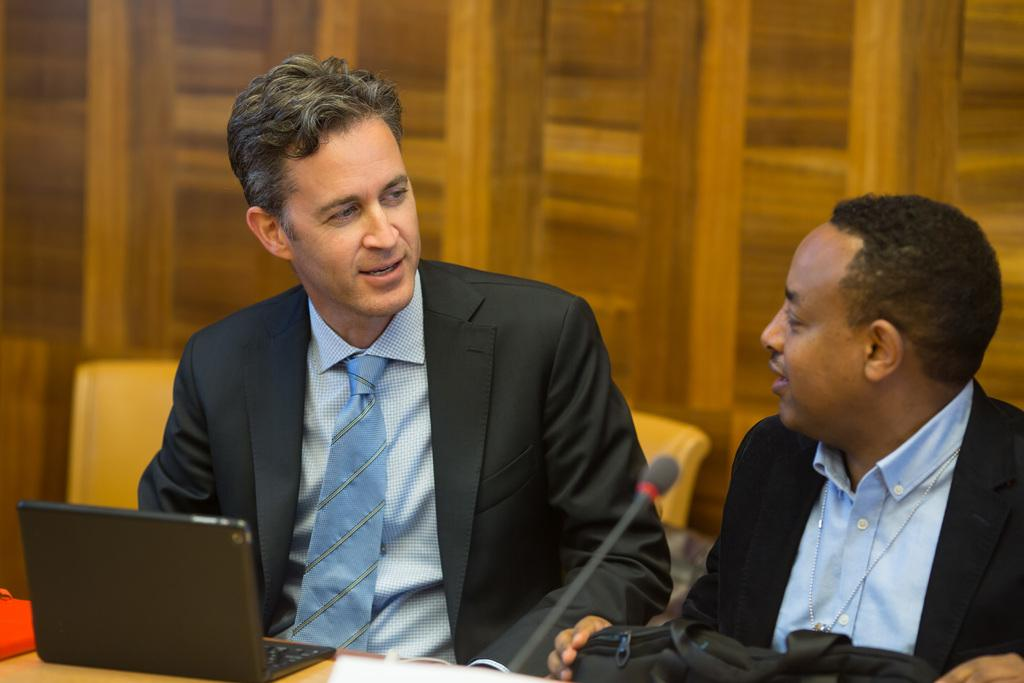Who or what can be seen in the image? There are people in the image. What object is present that is typically used for amplifying sound? There is a microphone (mike) in the image. What is located in the foreground of the image? There is a table with objects on it in the foreground. What type of furniture is present in the image? There are chairs in the image. What material might be used to create the wooden object in the background? There appears to be a wooden object in the background. What type of cast can be seen on the person's leg in the image? There is no cast visible on anyone's leg in the image. What type of sidewalk can be seen in the image? There is no sidewalk present in the image. 